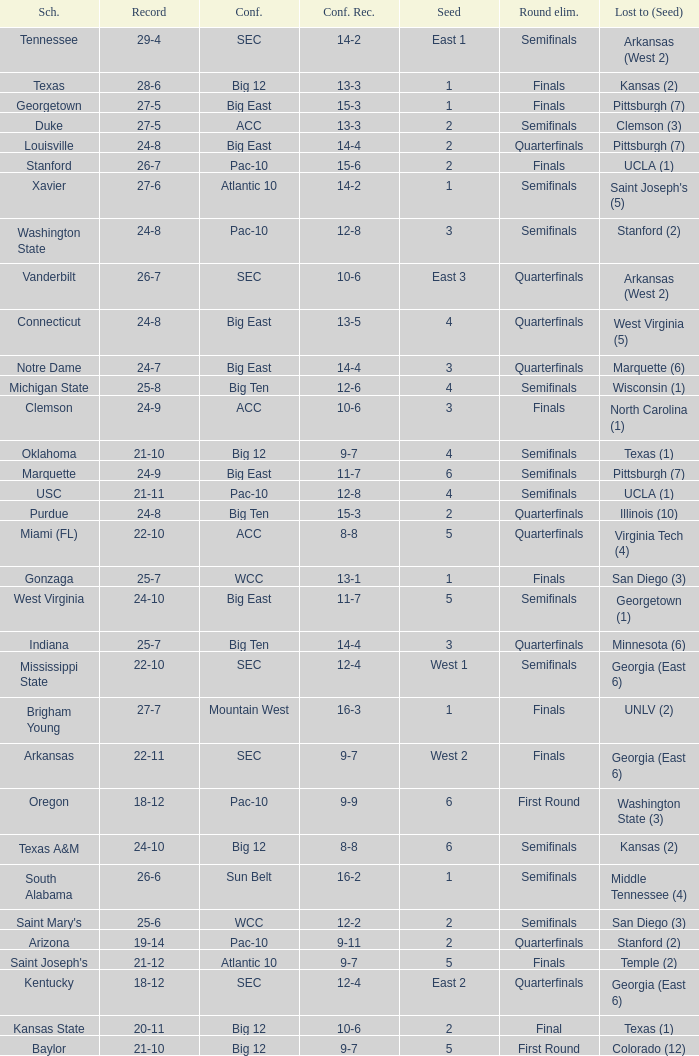Which round saw the removal of a team with a conference score of 12-6? Semifinals. 